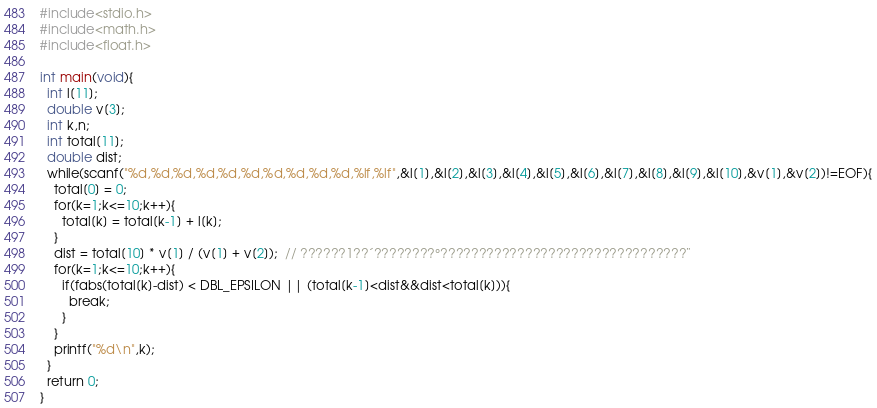Convert code to text. <code><loc_0><loc_0><loc_500><loc_500><_C_>#include<stdio.h>
#include<math.h>
#include<float.h>

int main(void){
  int l[11];
  double v[3];
  int k,n;
  int total[11];
  double dist;
  while(scanf("%d,%d,%d,%d,%d,%d,%d,%d,%d,%d,%lf,%lf",&l[1],&l[2],&l[3],&l[4],&l[5],&l[6],&l[7],&l[8],&l[9],&l[10],&v[1],&v[2])!=EOF){
    total[0] = 0;
    for(k=1;k<=10;k++){
      total[k] = total[k-1] + l[k];
    }
    dist = total[10] * v[1] / (v[1] + v[2]);  // ??????1??´????????°????????????????????????????????¨
    for(k=1;k<=10;k++){
      if(fabs(total[k]-dist) < DBL_EPSILON || (total[k-1]<dist&&dist<total[k])){
        break;
      }
    }
    printf("%d\n",k);
  }
  return 0;
}</code> 